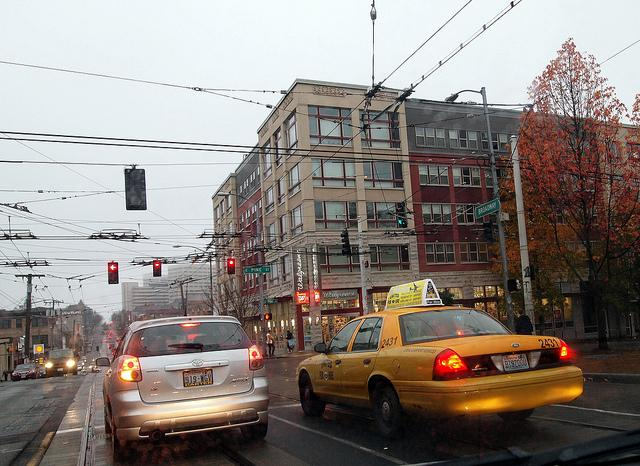Which car is stopped before white line?

Choices:
A) both
B) toyota
C) neither
D) cab cab 